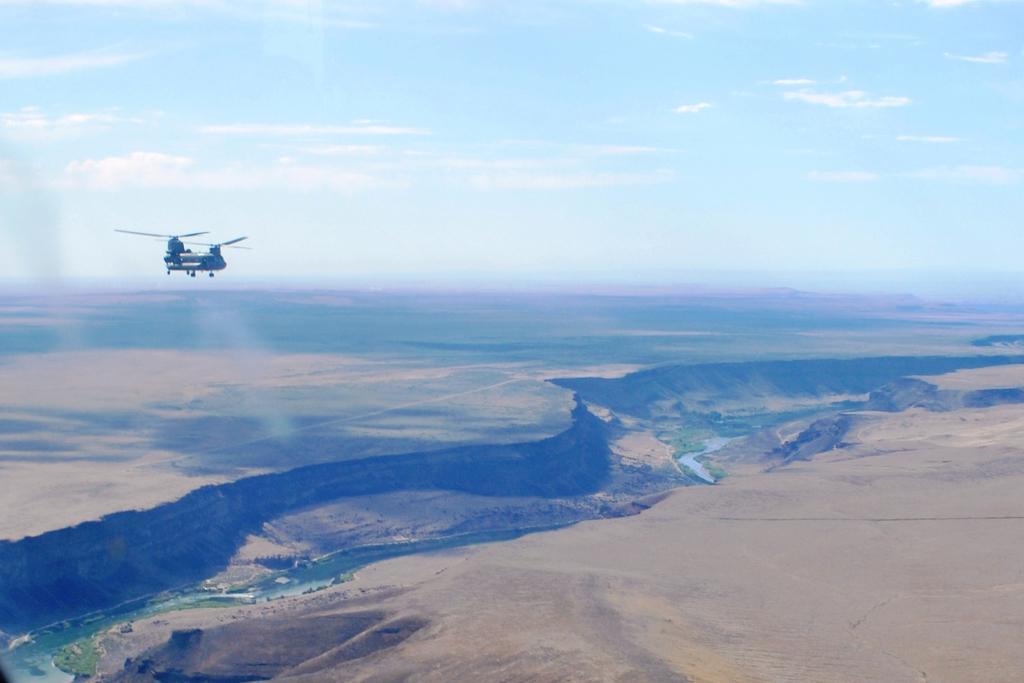Describe this image in one or two sentences. In this image there is a helicopter in the air. There is water. At the bottom of the image there is sand. At the top of the image there are clouds in the sky. 